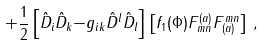<formula> <loc_0><loc_0><loc_500><loc_500>+ \frac { 1 } { 2 } \left [ { \hat { D } } _ { i } { \hat { D } } _ { k } { - } g _ { i k } { \hat { D } } ^ { l } { \hat { D } } _ { l } \right ] \left [ f _ { 1 } ( \Phi ) F ^ { ( a ) } _ { m n } F ^ { m n } _ { ( a ) } \right ] \, ,</formula> 